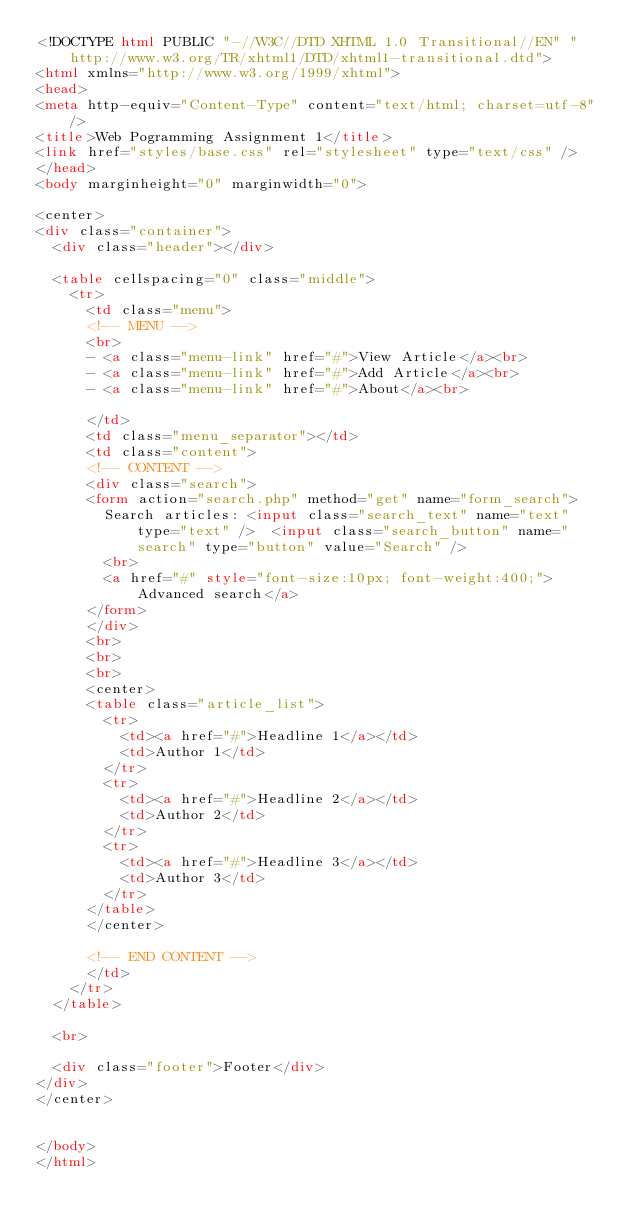Convert code to text. <code><loc_0><loc_0><loc_500><loc_500><_HTML_><!DOCTYPE html PUBLIC "-//W3C//DTD XHTML 1.0 Transitional//EN" "http://www.w3.org/TR/xhtml1/DTD/xhtml1-transitional.dtd">
<html xmlns="http://www.w3.org/1999/xhtml">
<head>
<meta http-equiv="Content-Type" content="text/html; charset=utf-8" />
<title>Web Pogramming Assignment 1</title>
<link href="styles/base.css" rel="stylesheet" type="text/css" />
</head>
<body marginheight="0" marginwidth="0">

<center>
<div class="container">
  <div class="header"></div>
  
  <table cellspacing="0" class="middle">
    <tr>
      <td class="menu">
      <!-- MENU -->
      <br>
      - <a class="menu-link" href="#">View Article</a><br>
      - <a class="menu-link" href="#">Add Article</a><br>
      - <a class="menu-link" href="#">About</a><br>
      
      </td>
      <td class="menu_separator"></td>
      <td class="content">
      <!-- CONTENT -->
      <div class="search">
      <form action="search.php" method="get" name="form_search">
        Search articles: <input class="search_text" name="text" type="text" />  <input class="search_button" name="search" type="button" value="Search" />
        <br>
        <a href="#" style="font-size:10px; font-weight:400;">Advanced search</a>
      </form>
      </div>
      <br>
      <br>
      <br>
	  <center>
      <table class="article_list">
        <tr>
          <td><a href="#">Headline 1</a></td>
          <td>Author 1</td>
        </tr>
        <tr>
          <td><a href="#">Headline 2</a></td>
          <td>Author 2</td>
        </tr>
        <tr>
          <td><a href="#">Headline 3</a></td>
          <td>Author 3</td>
        </tr>
      </table>
      </center>
      
      <!-- END CONTENT -->
      </td>
    </tr>
  </table>
 
  <br>
  
  <div class="footer">Footer</div>
</div>
</center>


</body>
</html>
</code> 